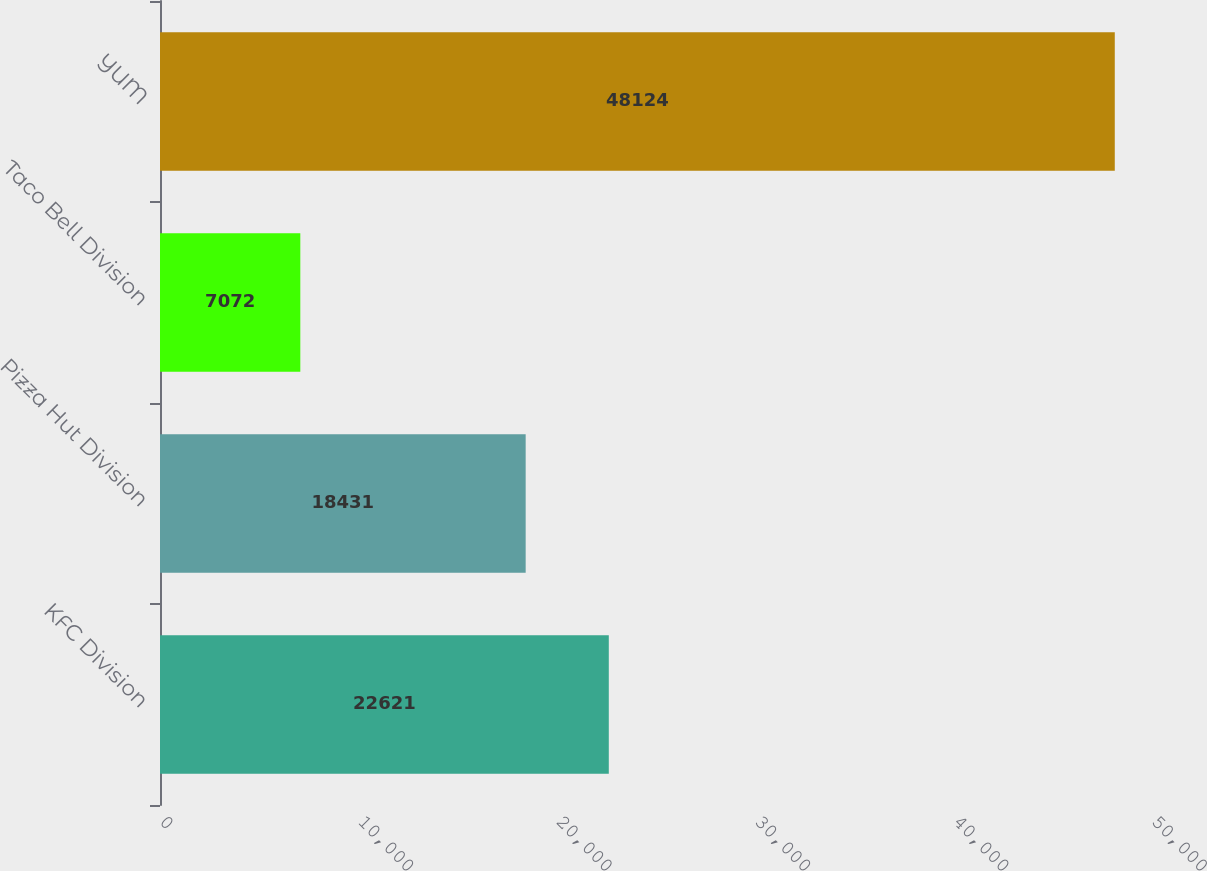Convert chart to OTSL. <chart><loc_0><loc_0><loc_500><loc_500><bar_chart><fcel>KFC Division<fcel>Pizza Hut Division<fcel>Taco Bell Division<fcel>YUM<nl><fcel>22621<fcel>18431<fcel>7072<fcel>48124<nl></chart> 